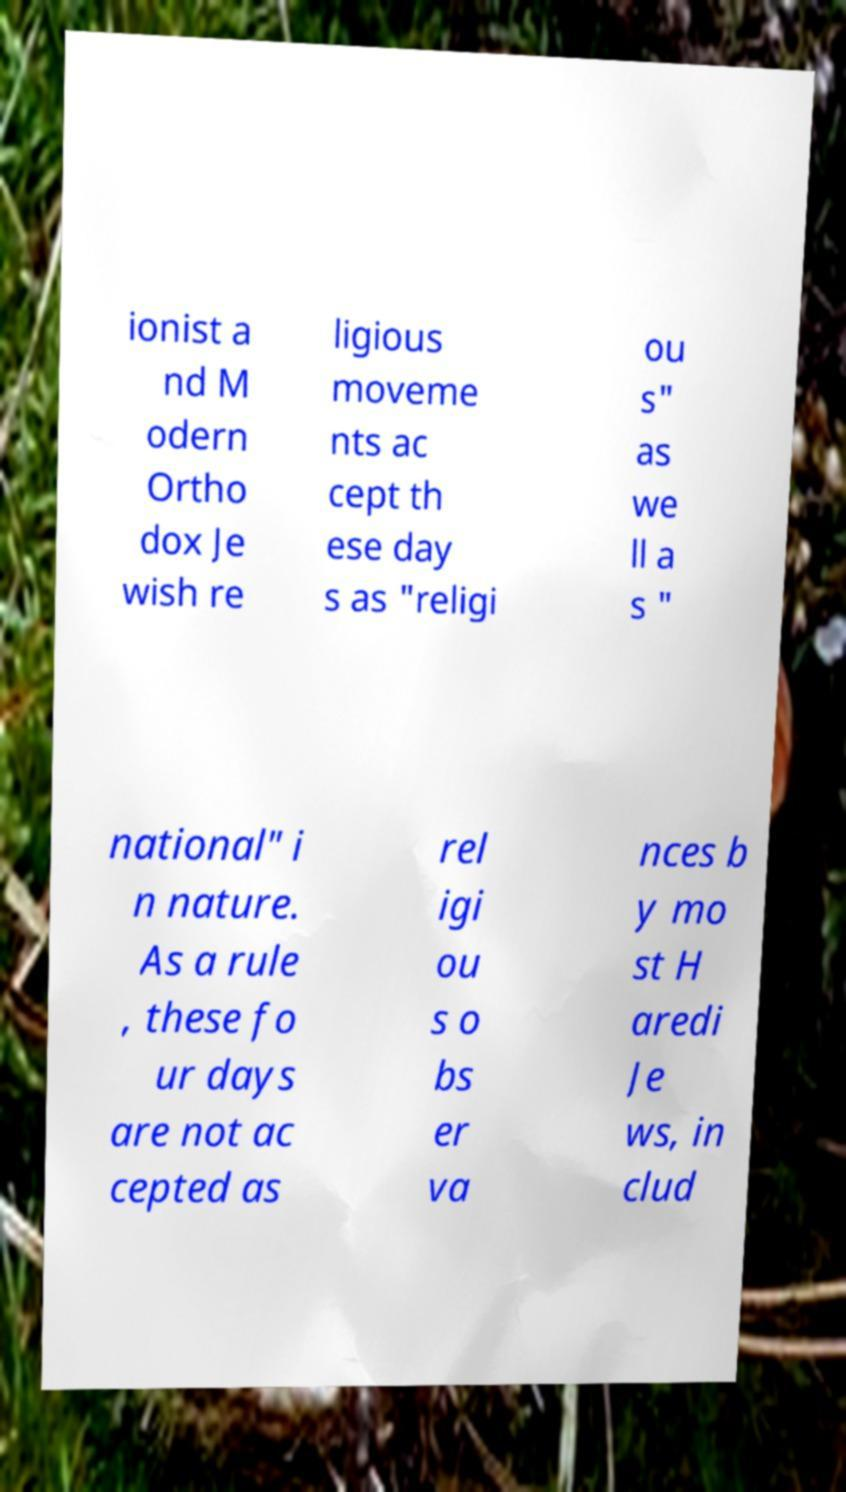Could you assist in decoding the text presented in this image and type it out clearly? ionist a nd M odern Ortho dox Je wish re ligious moveme nts ac cept th ese day s as "religi ou s" as we ll a s " national" i n nature. As a rule , these fo ur days are not ac cepted as rel igi ou s o bs er va nces b y mo st H aredi Je ws, in clud 